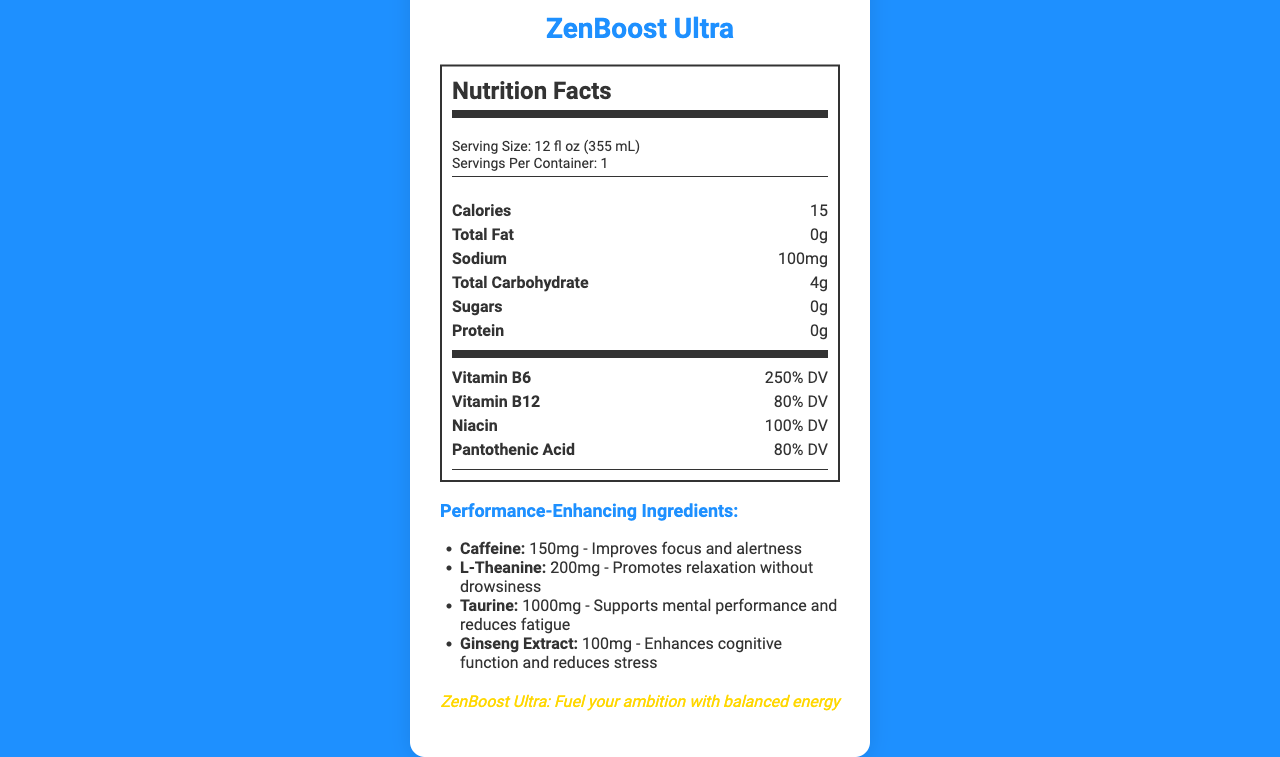what is the serving size of ZenBoost Ultra? The serving size is specified under the "Serving Size" heading in the nutrition facts section.
Answer: 12 fl oz (355 mL) how many calories are in one serving of ZenBoost Ultra? The calorie content is clearly listed as 15 calories in the main nutrients section.
Answer: 15 what is the amount of sodium present in ZenBoost Ultra? Sodium content is listed under the "Sodium" label in the main nutrients section.
Answer: 100mg which vitamins are present in the drink and what are their daily values? The daily values for these vitamins are listed in the vitamins section.
Answer: Vitamin B6: 250% DV, Vitamin B12: 80% DV, Niacin: 100% DV, Pantothenic Acid: 80% DV identify the ingredient that promotes relaxation without drowsiness L-Theanine, listed under performance-enhancing ingredients, promotes relaxation without drowsiness.
Answer: L-Theanine which of the following is NOT a feature of ZenBoost Ultra? A. High-calorie formula B. Zero sugar C. Scientifically formulated for peak performance D. Supports mental clarity and physical endurance The product is specifically described as having a low-calorie formula, not high-calorie.
Answer: A where is the primary color of the packaging design used? A. Background of the container B. Text color C. Accent color of the design D. Logo placement The primary color is used as the background color of the container.
Answer: A does ZenBoost Ultra contain any protein? The nutrition facts section specifies that the protein content is 0g.
Answer: No explain the main purpose of the performance-enhancing ingredients in ZenBoost Ultra The listed benefits next to each ingredient highlight various cognitive and physical performance enhancements.
Answer: The performance-enhancing ingredients are designed to improve focus, alertness, relaxation, cognitive function, and reduce fatigue. how is ZenBoost Ultra marketed towards sustainability? The sustainability note specifies that the can is made from 100% recyclable materials.
Answer: Can made from 100% recyclable materials identify the target audience for ZenBoost Ultra from the document The target audience is explicitly mentioned at the end of the document.
Answer: Ambitious professionals, entrepreneurs, and executives list the flavors or taste of ZenBoost Ultra Flavor or taste is not specified in the document; only "Natural Flavors" is mentioned in the ingredients but no specific flavor is listed.
Answer: Not enough information summarize the main idea of the document The document highlights various aspects of ZenBoost Ultra, including its nutritional content, performance-enhancing benefits, target audience, design features, and distribution channels.
Answer: ZenBoost Ultra is a low-calorie energy drink designed for performance enhancement. It features vitamins and proprietary ingredients to boost mental and physical performance, specifically targeting ambitious professionals. The product is marketed with modern aesthetics and a sustainability angle. 